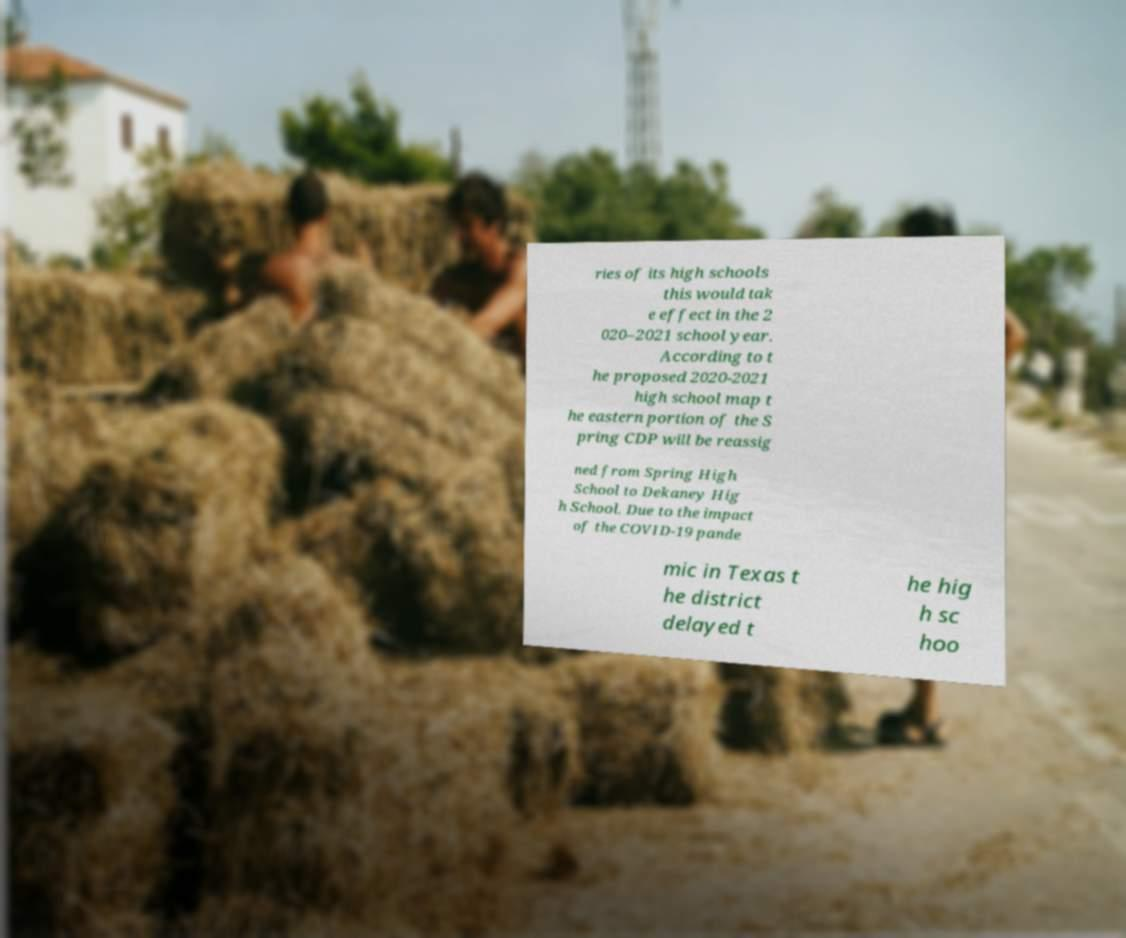Could you assist in decoding the text presented in this image and type it out clearly? ries of its high schools this would tak e effect in the 2 020–2021 school year. According to t he proposed 2020-2021 high school map t he eastern portion of the S pring CDP will be reassig ned from Spring High School to Dekaney Hig h School. Due to the impact of the COVID-19 pande mic in Texas t he district delayed t he hig h sc hoo 